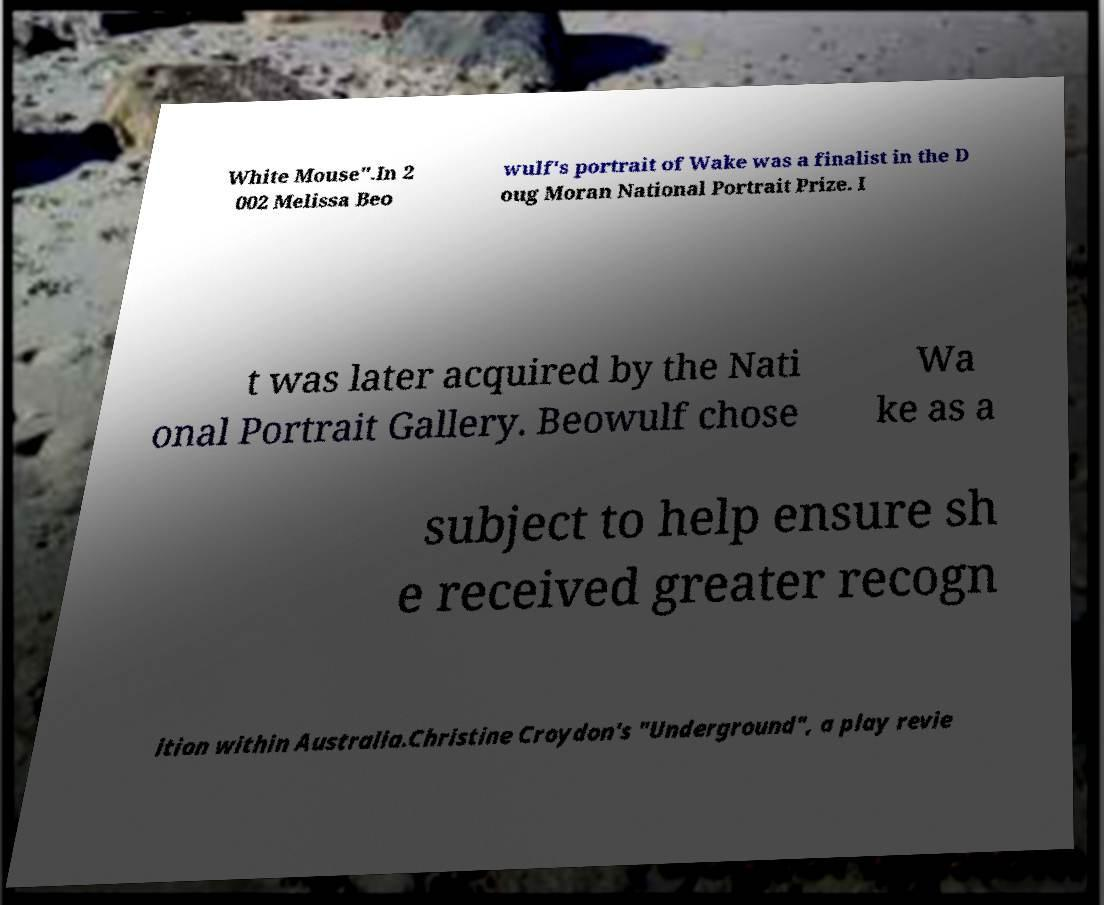There's text embedded in this image that I need extracted. Can you transcribe it verbatim? White Mouse".In 2 002 Melissa Beo wulf's portrait of Wake was a finalist in the D oug Moran National Portrait Prize. I t was later acquired by the Nati onal Portrait Gallery. Beowulf chose Wa ke as a subject to help ensure sh e received greater recogn ition within Australia.Christine Croydon's "Underground", a play revie 